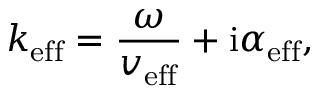<formula> <loc_0><loc_0><loc_500><loc_500>k _ { e f f } = \frac { \omega } { v _ { e f f } } + i \alpha _ { e f f } ,</formula> 